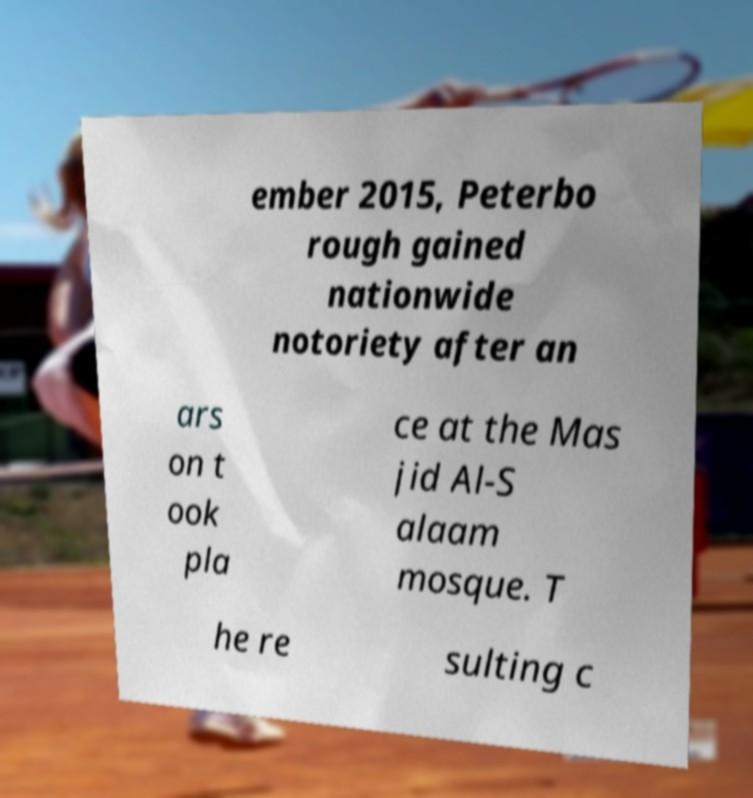Can you accurately transcribe the text from the provided image for me? ember 2015, Peterbo rough gained nationwide notoriety after an ars on t ook pla ce at the Mas jid Al-S alaam mosque. T he re sulting c 